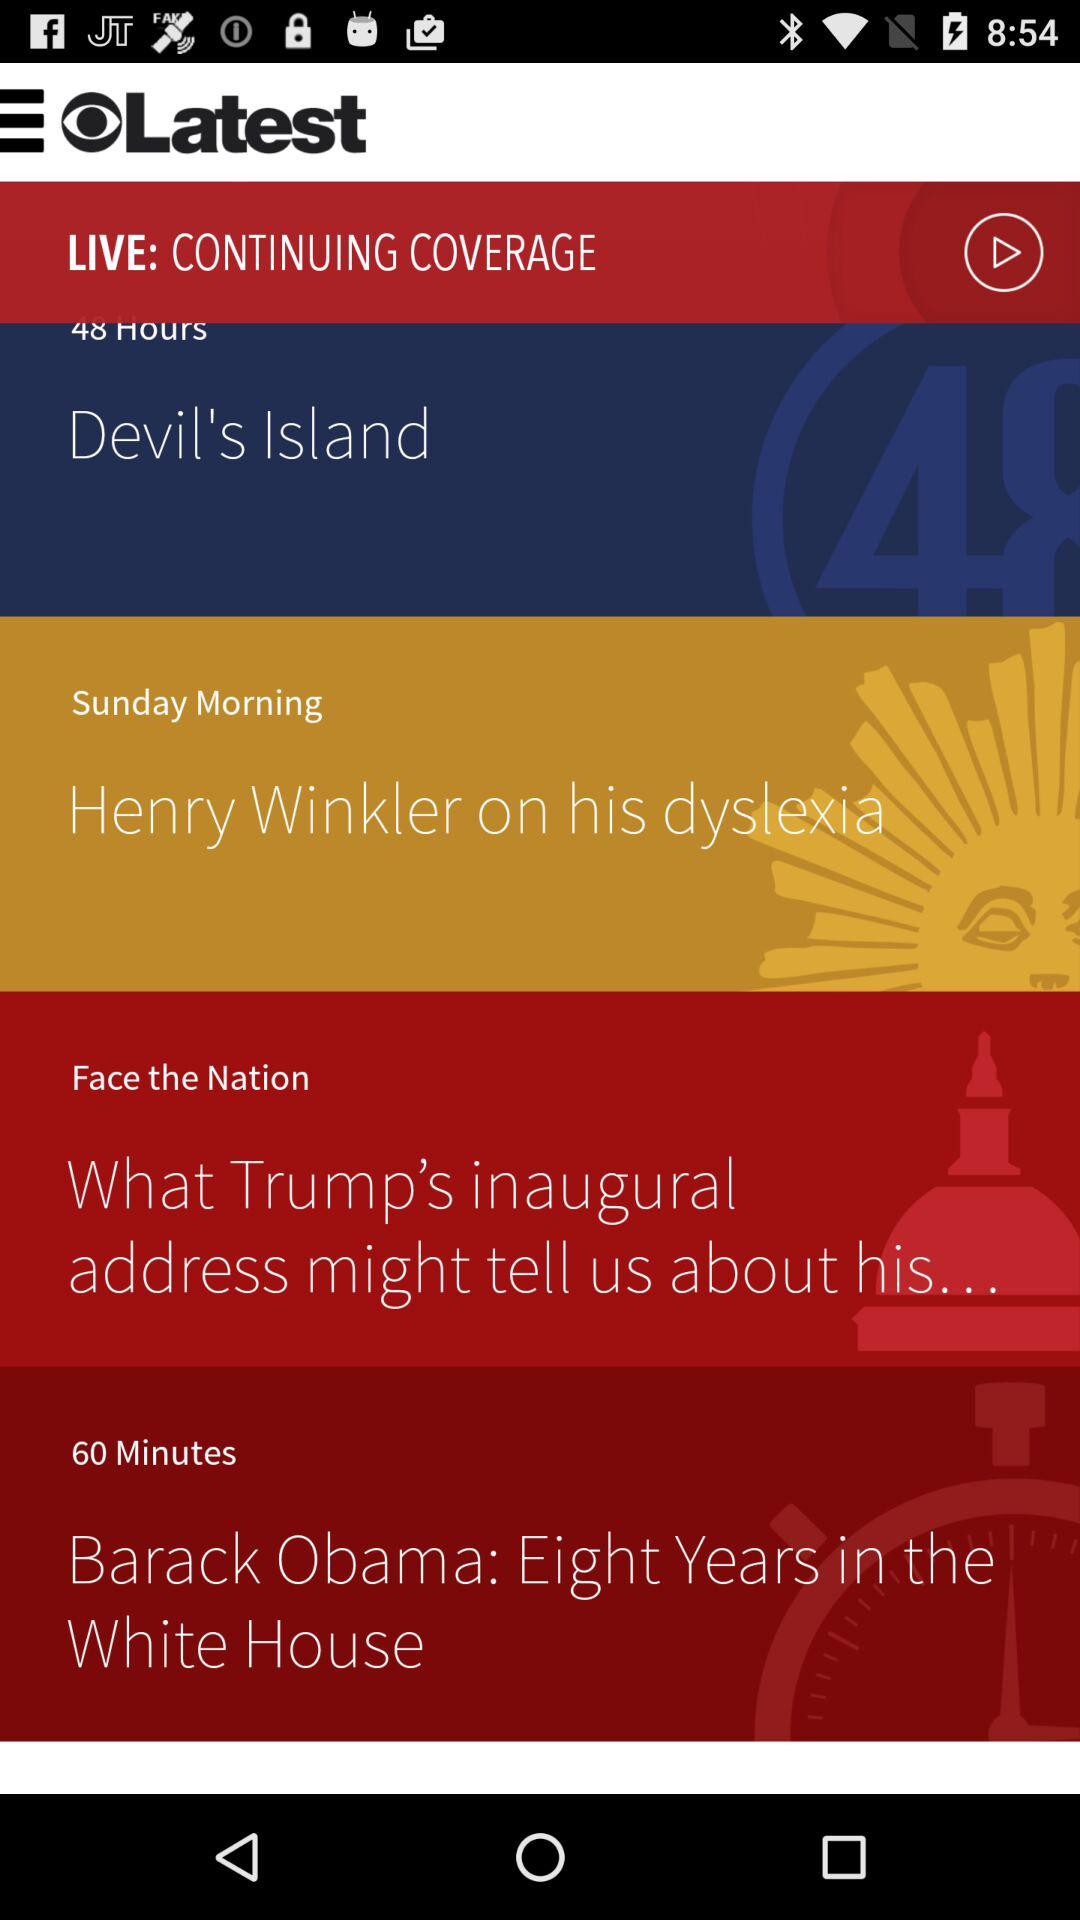What is the application name? The application name is "CBS News". 